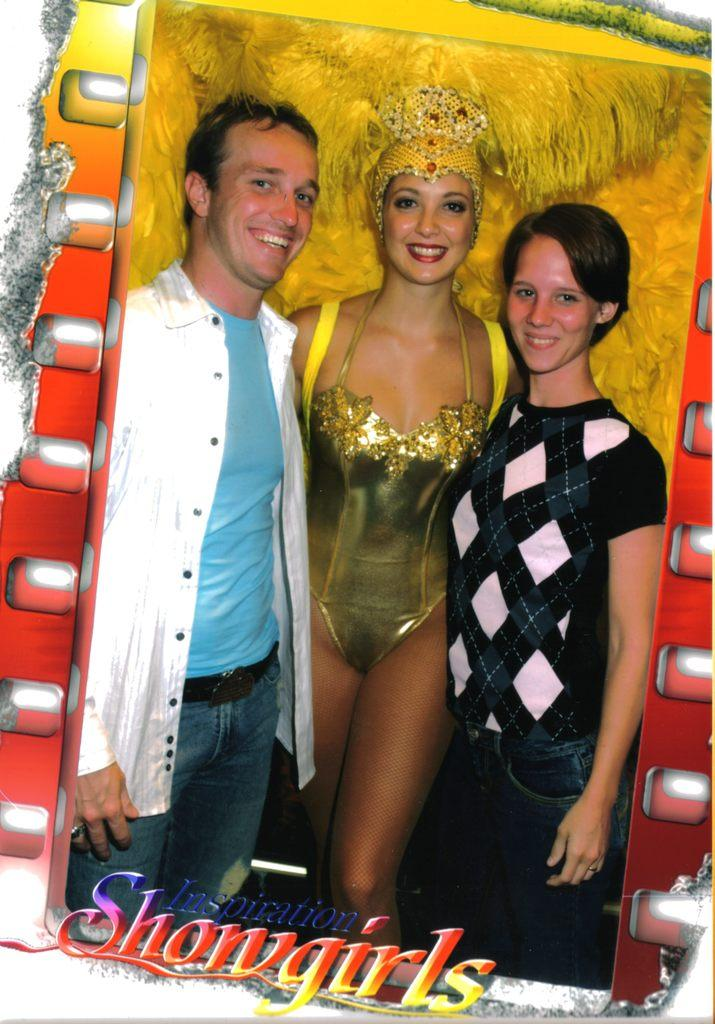What object is present in the image that typically holds a photograph? There is a photo frame in the image. How many people are visible in the photo frame? There are three people in the photo frame. What type of planes are flying in the background of the image? There are no planes visible in the image; it only features a photo frame with three people. Can you describe the friction between the people in the photo frame? There is no friction between the people in the photo frame, as it is a still image. 